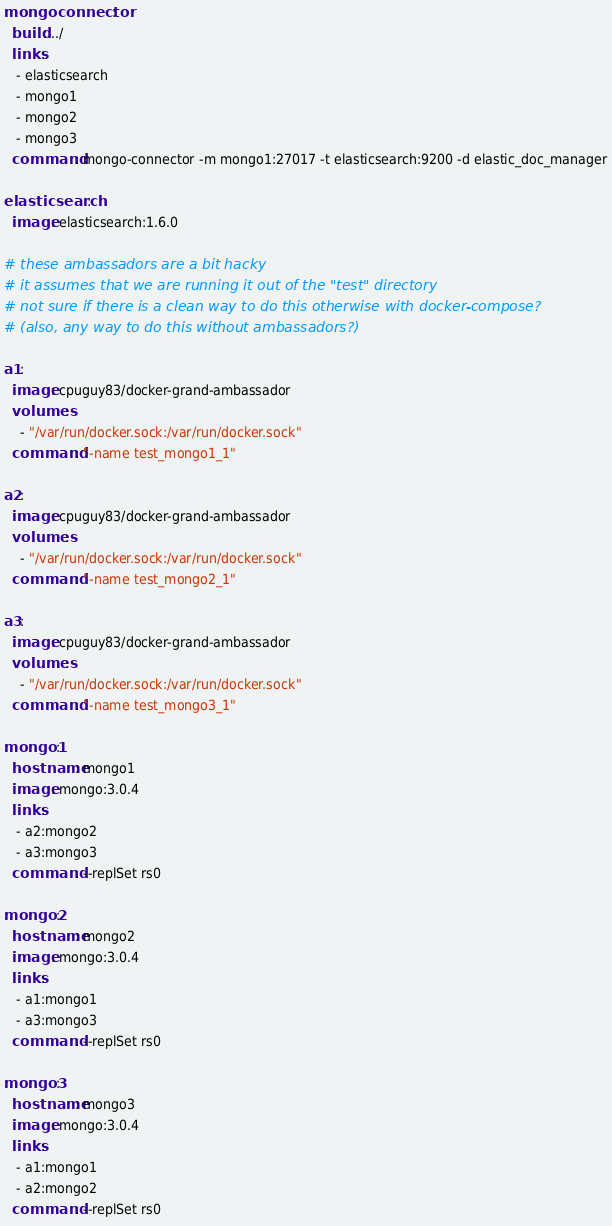Convert code to text. <code><loc_0><loc_0><loc_500><loc_500><_YAML_>mongoconnector:
  build: ../
  links:
   - elasticsearch
   - mongo1
   - mongo2
   - mongo3
  command: mongo-connector -m mongo1:27017 -t elasticsearch:9200 -d elastic_doc_manager

elasticsearch:
  image: elasticsearch:1.6.0

# these ambassadors are a bit hacky
# it assumes that we are running it out of the "test" directory
# not sure if there is a clean way to do this otherwise with docker-compose?
# (also, any way to do this without ambassadors?)

a1:
  image: cpuguy83/docker-grand-ambassador
  volumes:
    - "/var/run/docker.sock:/var/run/docker.sock"
  command: "-name test_mongo1_1"

a2:
  image: cpuguy83/docker-grand-ambassador
  volumes:
    - "/var/run/docker.sock:/var/run/docker.sock"
  command: "-name test_mongo2_1"

a3:
  image: cpuguy83/docker-grand-ambassador
  volumes:
    - "/var/run/docker.sock:/var/run/docker.sock"
  command: "-name test_mongo3_1"

mongo1:
  hostname: mongo1
  image: mongo:3.0.4
  links:
   - a2:mongo2
   - a3:mongo3
  command: --replSet rs0

mongo2:
  hostname: mongo2
  image: mongo:3.0.4
  links:
   - a1:mongo1
   - a3:mongo3
  command: --replSet rs0

mongo3:
  hostname: mongo3
  image: mongo:3.0.4
  links:
   - a1:mongo1
   - a2:mongo2
  command: --replSet rs0
</code> 